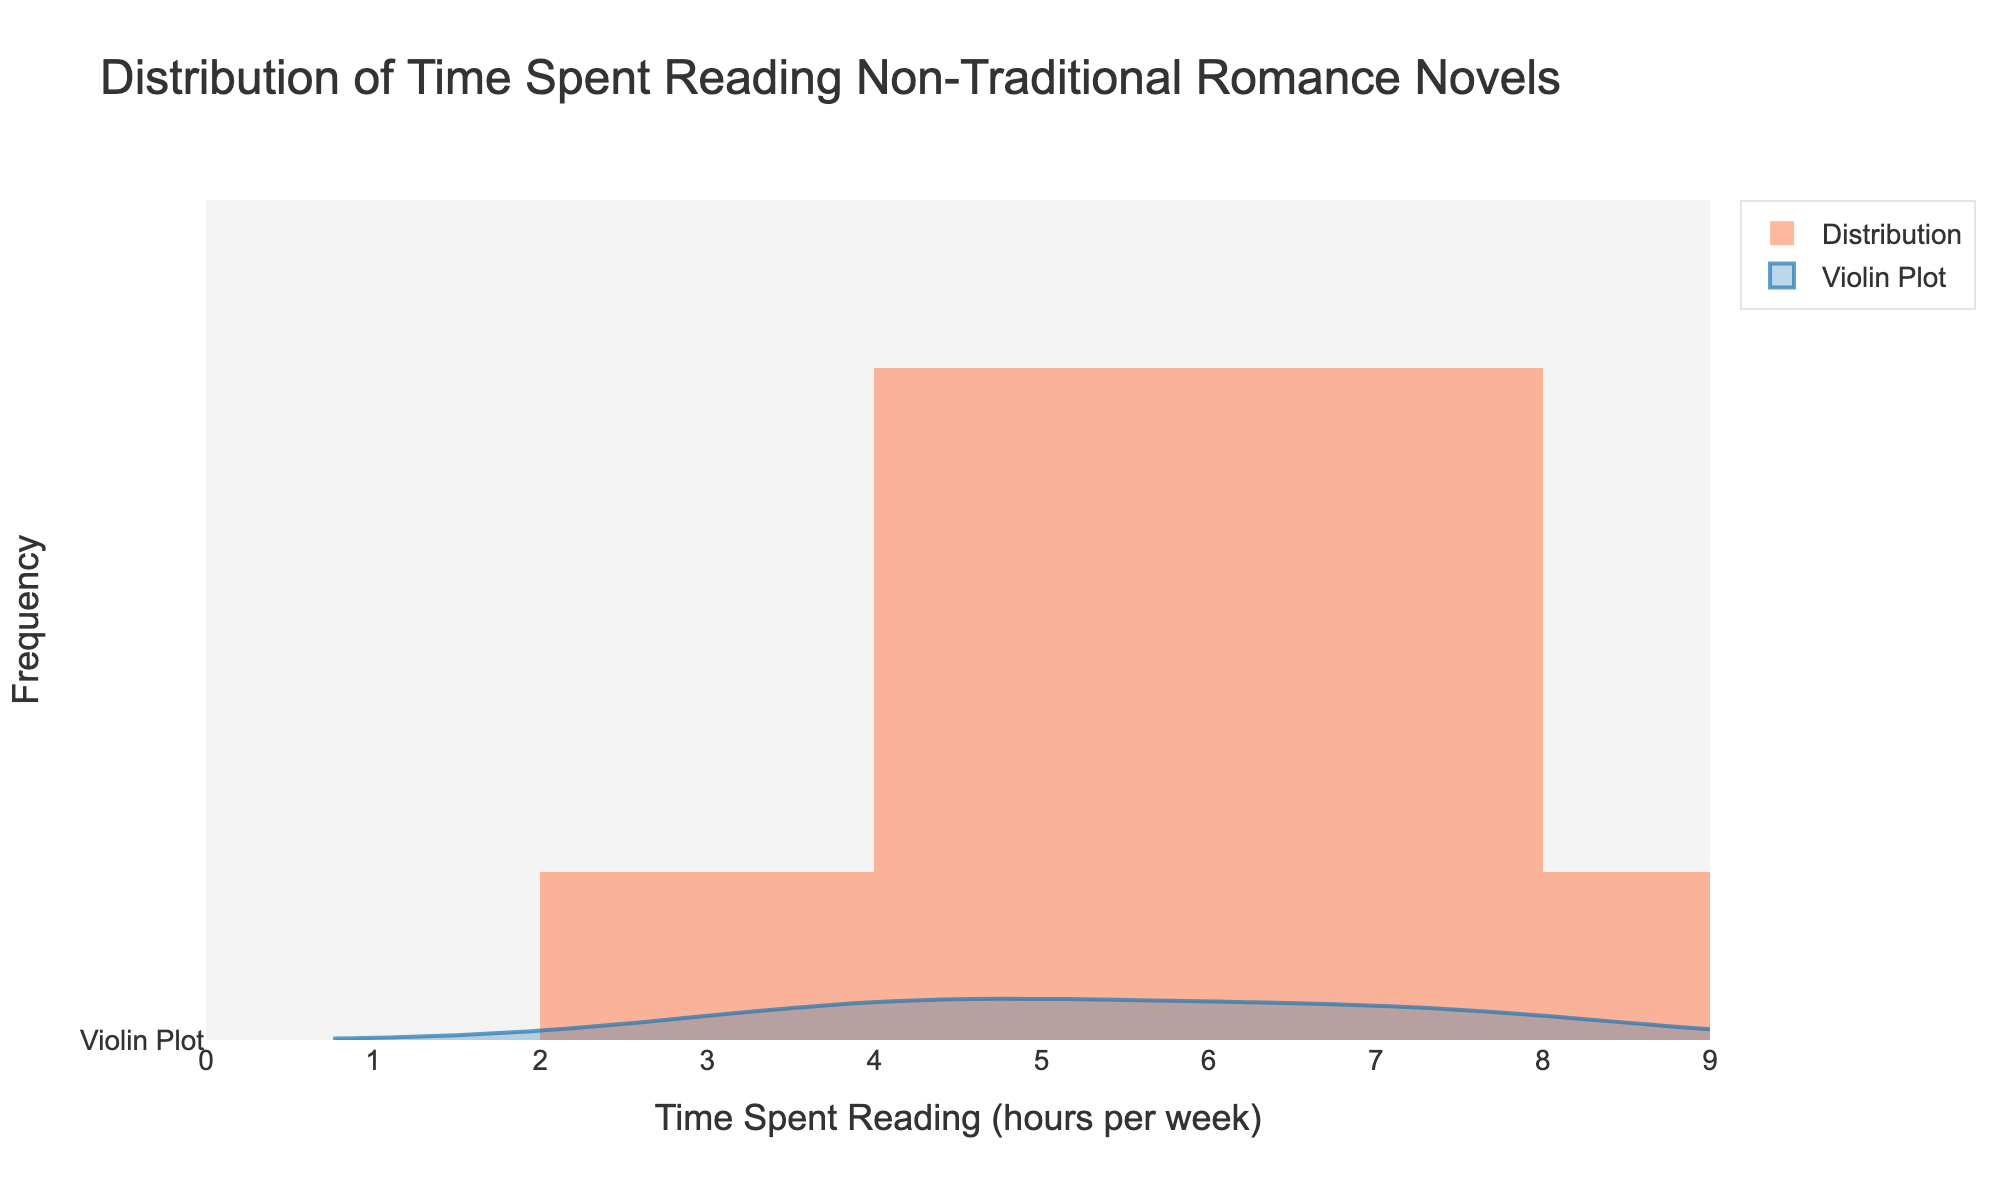What is the title of the figure? The title of the figure is displayed prominently at the top of the plot. It indicates the focus of the distribution being analyzed, which is the time spent reading non-traditional romance novels.
Answer: Distribution of Time Spent Reading Non-Traditional Romance Novels What is the color of the histogram bars? Observing the histogram bars, they are filled with a distinct color overlay. This color is not specified in coding terms but can be described as a bright, warm color.
Answer: Orange (specifically, a shade resembling coral) How many data points are represented in the plot? Each bar and data point in the violin plot represents a particular value from the dataset. Counting the individual entries used to generate the plot, there are ten data points in total, corresponding to the time spent by each reader.
Answer: 10 What is the range of time spent reading as shown on the x-axis? The x-axis captures the entire spectrum of reading times recorded. By examining the minimum and maximum bounds of the x-axis, it’s clear that the range starts at 0 hours and extends slightly beyond the highest data point.
Answer: 0 to 9 hours per week What is the median value of time spent reading according to the violin plot? The violin plot provides a visualization that includes the median value, typically represented by a central marker or line within the violin. The median indicates the middle value of the dataset.
Answer: 5.5 hours per week Which value appears most frequently in the histogram? The histogram allows for quick identification of the mode, which is the value with the highest bar. Observing the heights of the bars reveals which reading time is most commonly recorded among the data points.
Answer: 4 hours per week How does the spread of time spent reading appear in the violin plot? The violin plot showcases the distribution density of the data. By examining the width and shape of the plot, we can infer how spread out the values are and identify any concentrated areas. The plot’s shape suggests varying densities.
Answer: Most data points are between 3 and 7 hours What is the difference between the highest and lowest recorded times spent reading? To find this difference, identify the maximum and minimum values on the x-axis where the histogram has bars or the violin plot widens. Subtracting the smallest value from the largest gives the range of reading times.
Answer: 8 - 3 = 5 hours per week Would you consider the distribution to be symmetric, positively skewed, or negatively skewed? The shape and spread of both the histogram and the violin plot provide insights into the distribution's skewness. Symmetric distributions would look balanced on both sides, while skewed distributions lean more towards one side.
Answer: Positively skewed (more values clustered on the lower end) 